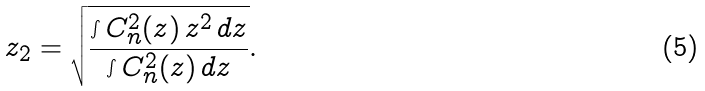Convert formula to latex. <formula><loc_0><loc_0><loc_500><loc_500>z _ { 2 } = \sqrt { \frac { \int C _ { n } ^ { 2 } ( z ) \, z ^ { 2 } \, d z } { \int C _ { n } ^ { 2 } ( z ) \, d z } } .</formula> 